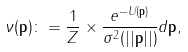Convert formula to latex. <formula><loc_0><loc_0><loc_500><loc_500>\nu ( \mathbf p ) \colon = \frac { 1 } { Z } \times \frac { e ^ { - U ( \mathbf p ) } } { \sigma ^ { 2 } ( | | \mathbf p | | ) } d \mathbf p ,</formula> 